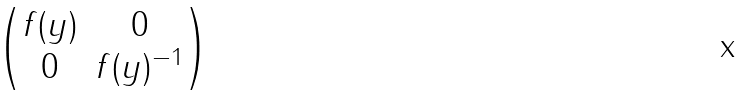Convert formula to latex. <formula><loc_0><loc_0><loc_500><loc_500>\begin{pmatrix} f ( y ) & 0 \\ 0 & f ( y ) ^ { - 1 } \end{pmatrix}</formula> 